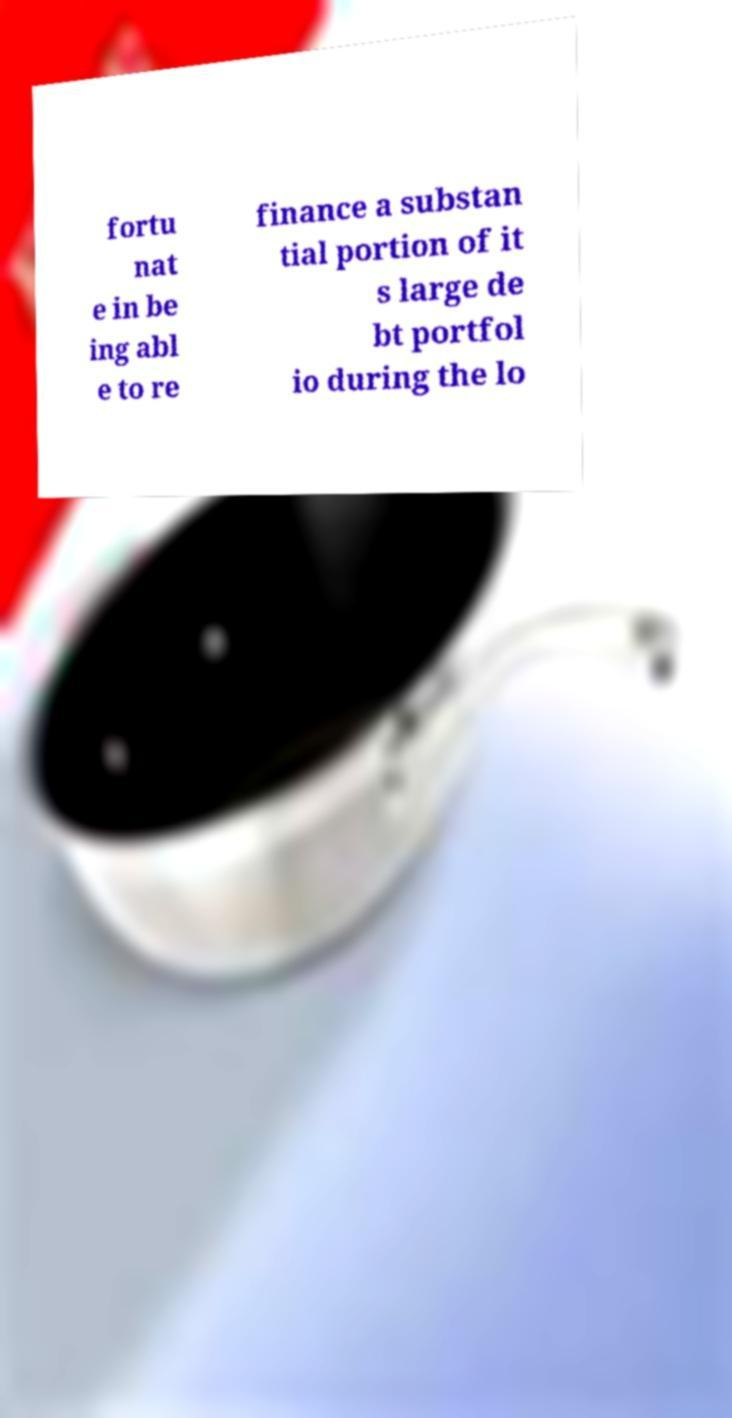Could you extract and type out the text from this image? fortu nat e in be ing abl e to re finance a substan tial portion of it s large de bt portfol io during the lo 